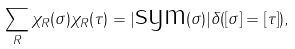<formula> <loc_0><loc_0><loc_500><loc_500>\sum _ { R } \chi _ { R } ( \sigma ) \chi _ { R } ( \tau ) = | \text {sym} ( \sigma ) | \delta ( [ \sigma ] = [ \tau ] ) ,</formula> 